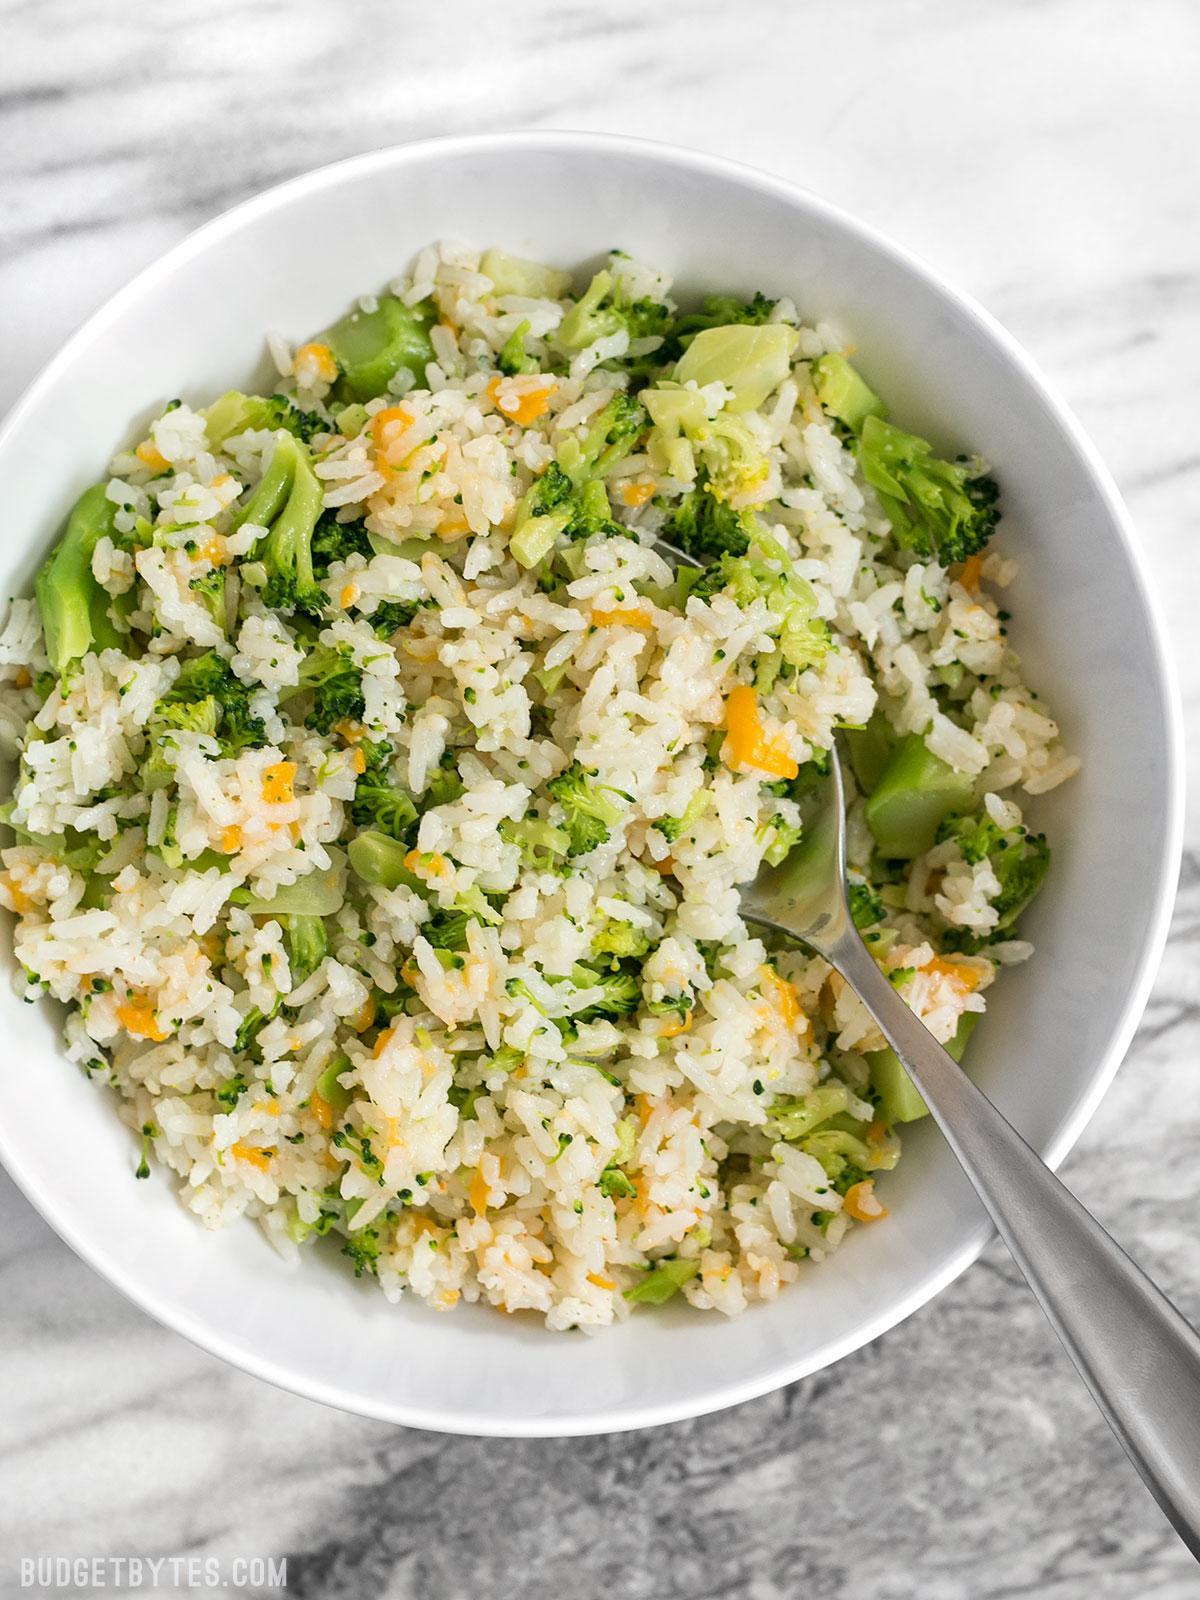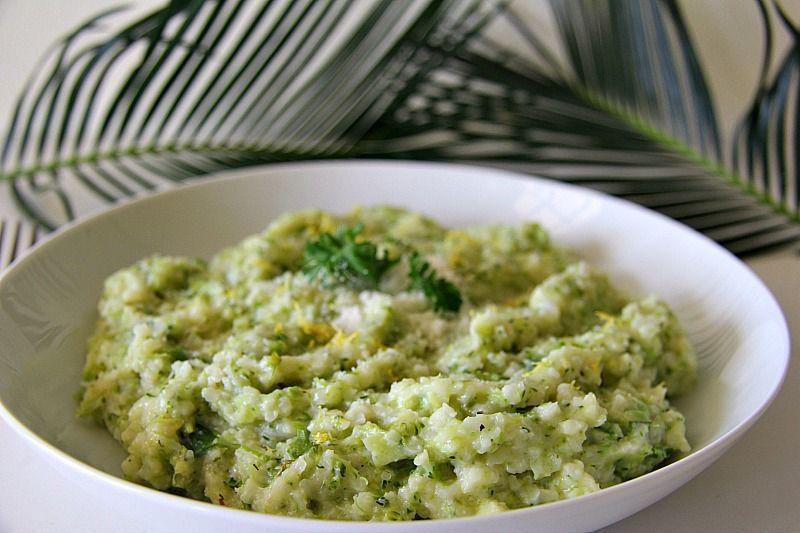The first image is the image on the left, the second image is the image on the right. Given the left and right images, does the statement "One image features whole broccoli pieces in a bowl." hold true? Answer yes or no. No. 